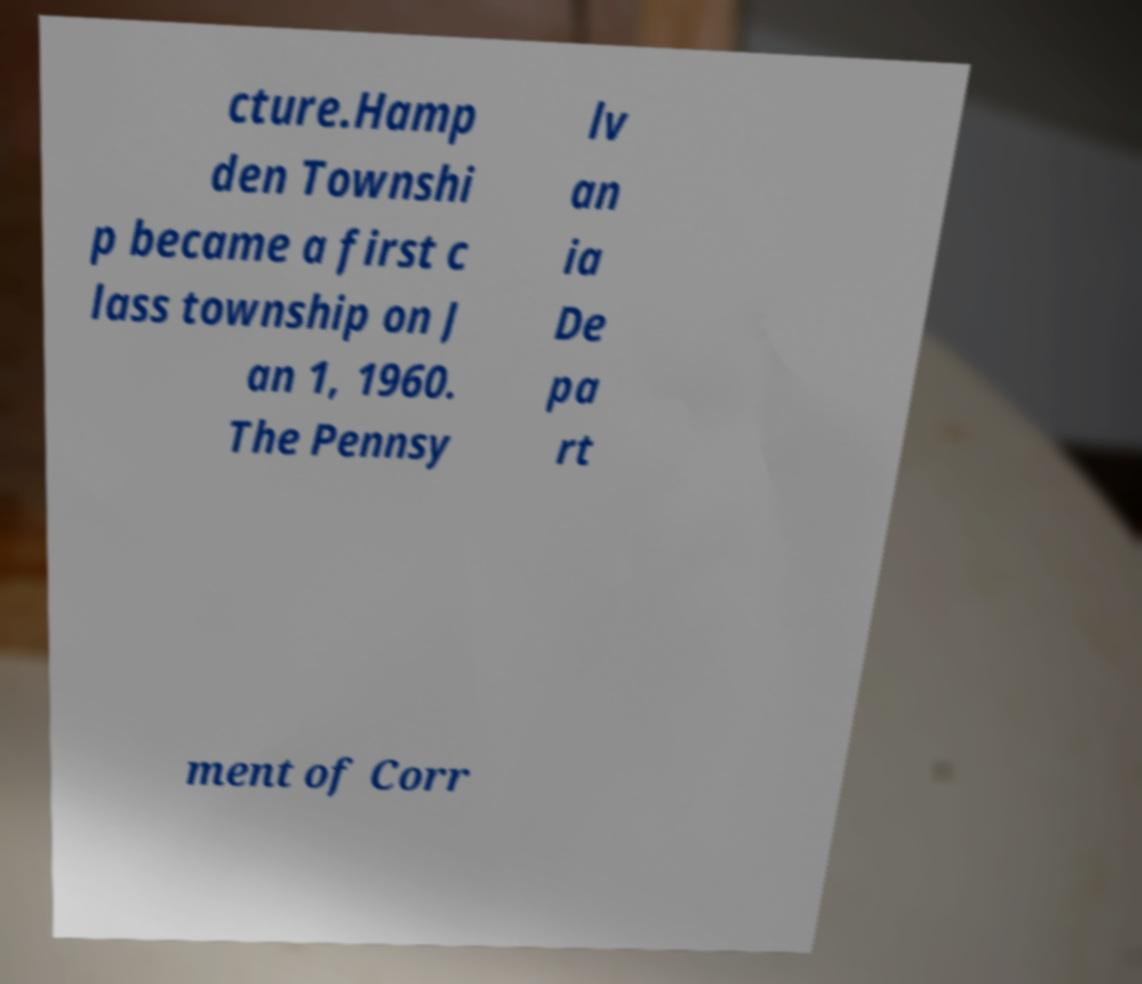Could you assist in decoding the text presented in this image and type it out clearly? cture.Hamp den Townshi p became a first c lass township on J an 1, 1960. The Pennsy lv an ia De pa rt ment of Corr 